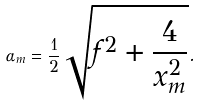<formula> <loc_0><loc_0><loc_500><loc_500>\alpha _ { m } = \frac { 1 } { 2 } \sqrt { f ^ { 2 } + \frac { 4 } { x _ { m } ^ { 2 } } } .</formula> 